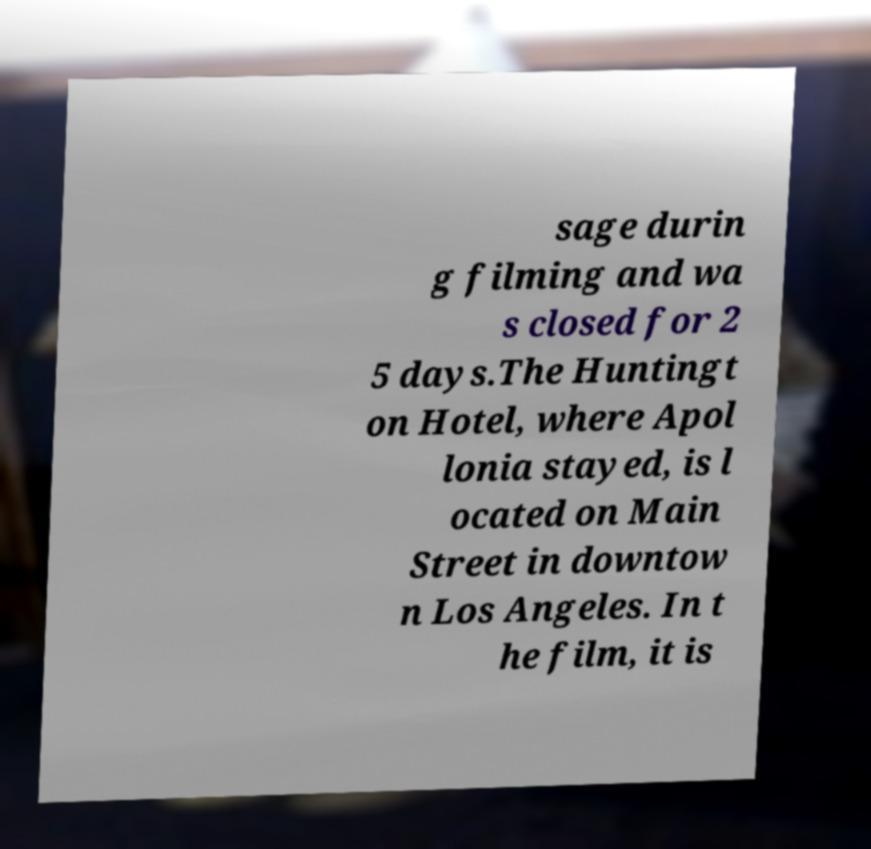For documentation purposes, I need the text within this image transcribed. Could you provide that? sage durin g filming and wa s closed for 2 5 days.The Huntingt on Hotel, where Apol lonia stayed, is l ocated on Main Street in downtow n Los Angeles. In t he film, it is 